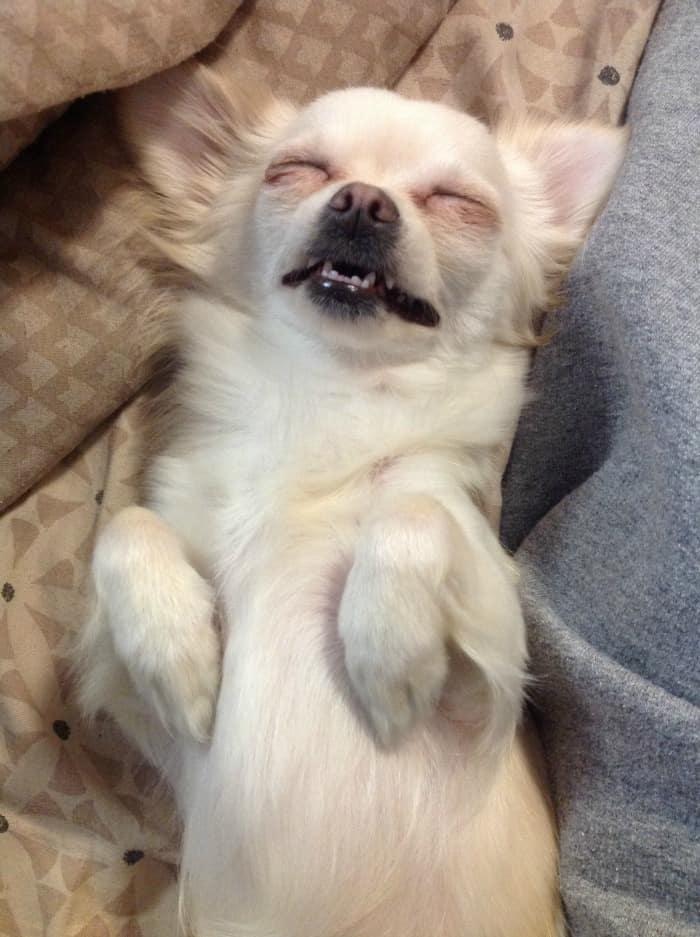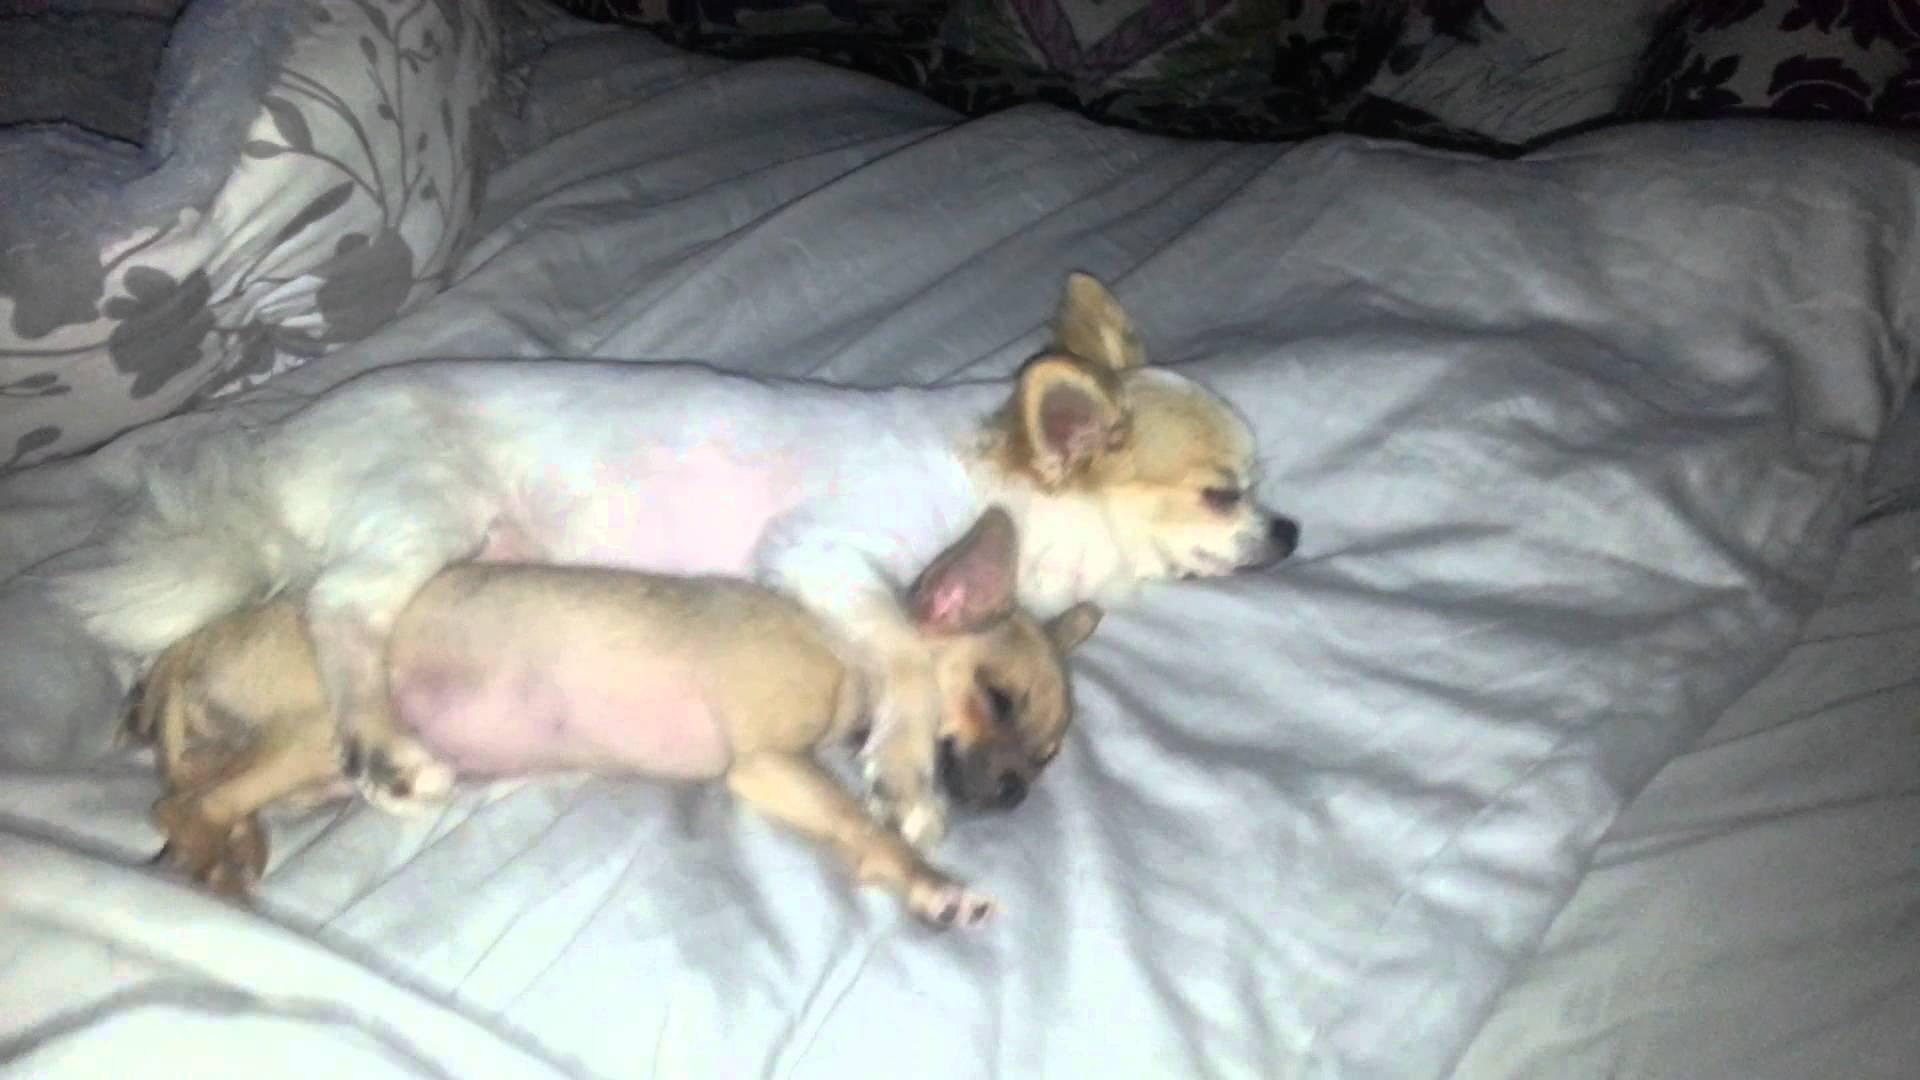The first image is the image on the left, the second image is the image on the right. Analyze the images presented: Is the assertion "Three dogs are lying down sleeping." valid? Answer yes or no. Yes. The first image is the image on the left, the second image is the image on the right. Given the left and right images, does the statement "All chihuahuas appear to be sleeping, and one image contains twice as many chihuahuas as the other image." hold true? Answer yes or no. Yes. 